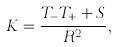Convert formula to latex. <formula><loc_0><loc_0><loc_500><loc_500>K = \frac { T _ { - } T _ { + } + S } { R ^ { 2 } } ,</formula> 